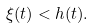<formula> <loc_0><loc_0><loc_500><loc_500>\xi ( t ) < h ( t ) .</formula> 